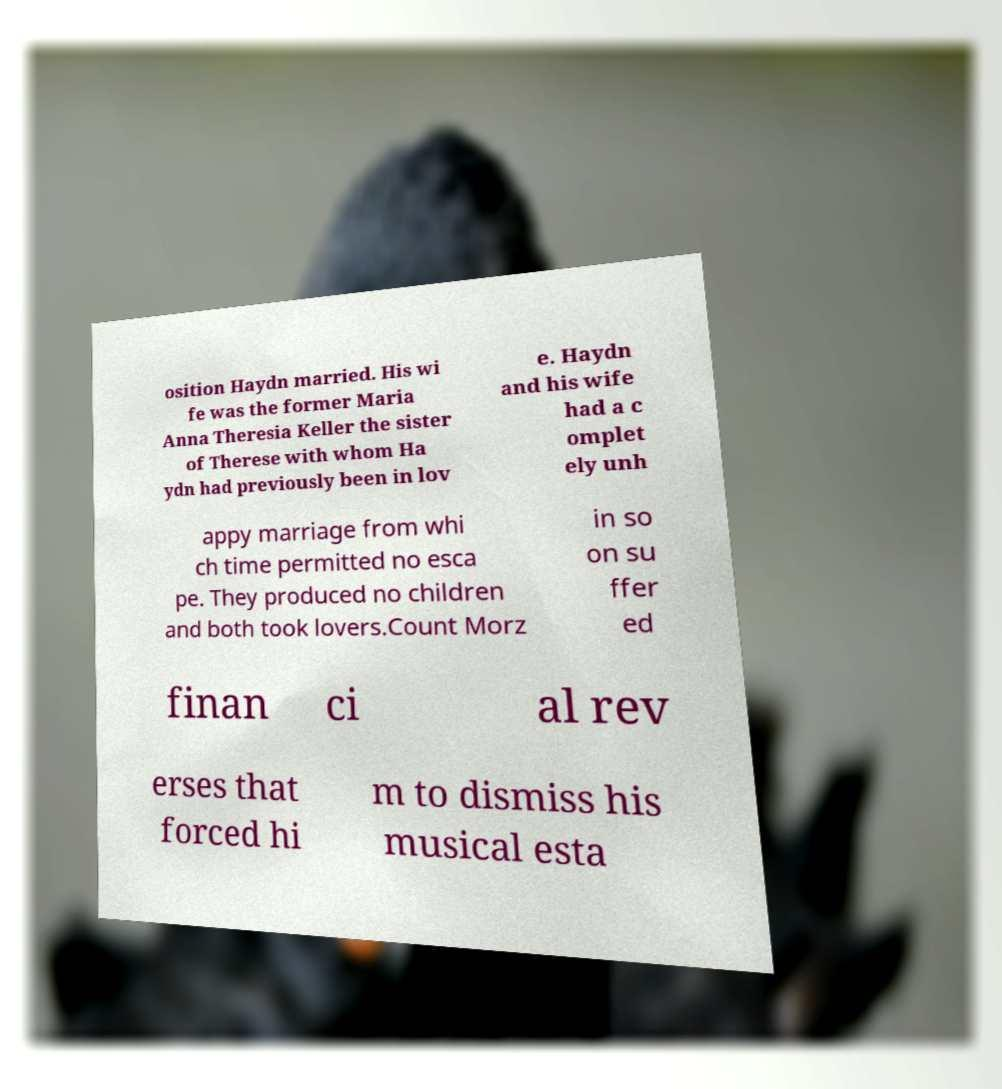For documentation purposes, I need the text within this image transcribed. Could you provide that? osition Haydn married. His wi fe was the former Maria Anna Theresia Keller the sister of Therese with whom Ha ydn had previously been in lov e. Haydn and his wife had a c omplet ely unh appy marriage from whi ch time permitted no esca pe. They produced no children and both took lovers.Count Morz in so on su ffer ed finan ci al rev erses that forced hi m to dismiss his musical esta 